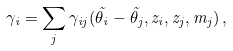Convert formula to latex. <formula><loc_0><loc_0><loc_500><loc_500>\gamma _ { i } = \sum _ { j } \gamma _ { i j } ( \vec { \theta } _ { i } - \vec { \theta } _ { j } , z _ { i } , z _ { j } , m _ { j } ) \, ,</formula> 